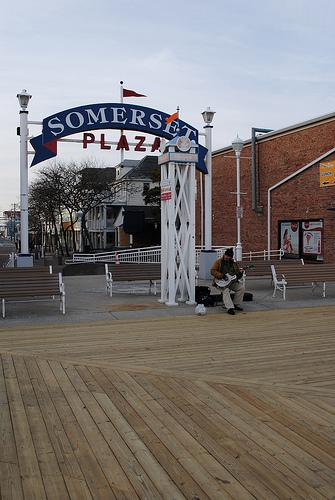Question: what is written in the board?
Choices:
A. Somerset Plaza.
B. Times Square.
C. North Road.
D. Sunset Boulevard.
Answer with the letter. Answer: A Question: how many lamp post are there?
Choices:
A. 3.
B. 2.
C. 1.
D. None.
Answer with the letter. Answer: A 